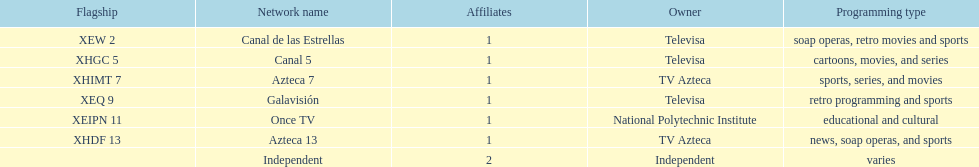What is the total number of affiliates among all the networks? 8. 